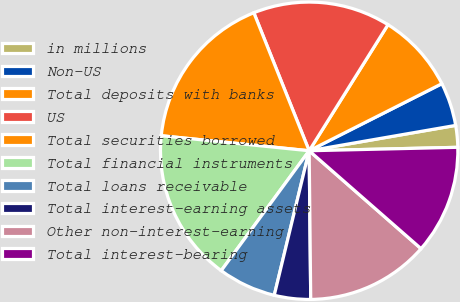Convert chart. <chart><loc_0><loc_0><loc_500><loc_500><pie_chart><fcel>in millions<fcel>Non-US<fcel>Total deposits with banks<fcel>US<fcel>Total securities borrowed<fcel>Total financial instruments<fcel>Total loans receivable<fcel>Total interest-earning assets<fcel>Other non-interest-earning<fcel>Total interest-bearing<nl><fcel>2.36%<fcel>4.72%<fcel>8.66%<fcel>14.96%<fcel>17.32%<fcel>16.54%<fcel>6.3%<fcel>3.94%<fcel>13.39%<fcel>11.81%<nl></chart> 